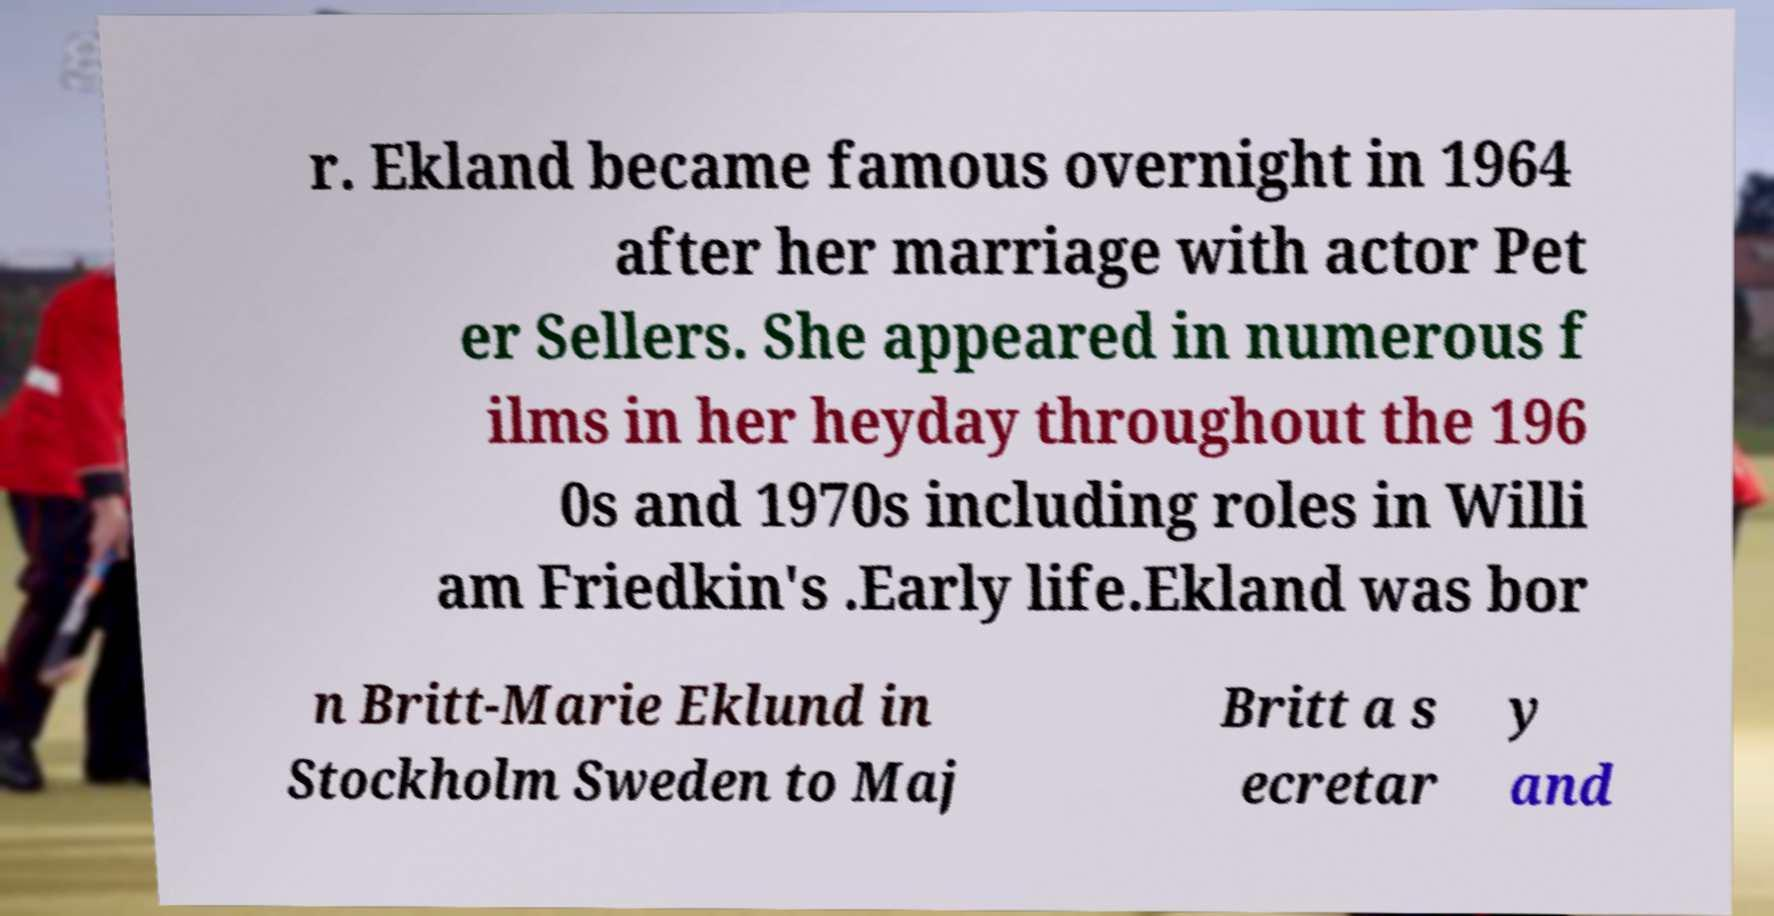Can you read and provide the text displayed in the image?This photo seems to have some interesting text. Can you extract and type it out for me? r. Ekland became famous overnight in 1964 after her marriage with actor Pet er Sellers. She appeared in numerous f ilms in her heyday throughout the 196 0s and 1970s including roles in Willi am Friedkin's .Early life.Ekland was bor n Britt-Marie Eklund in Stockholm Sweden to Maj Britt a s ecretar y and 